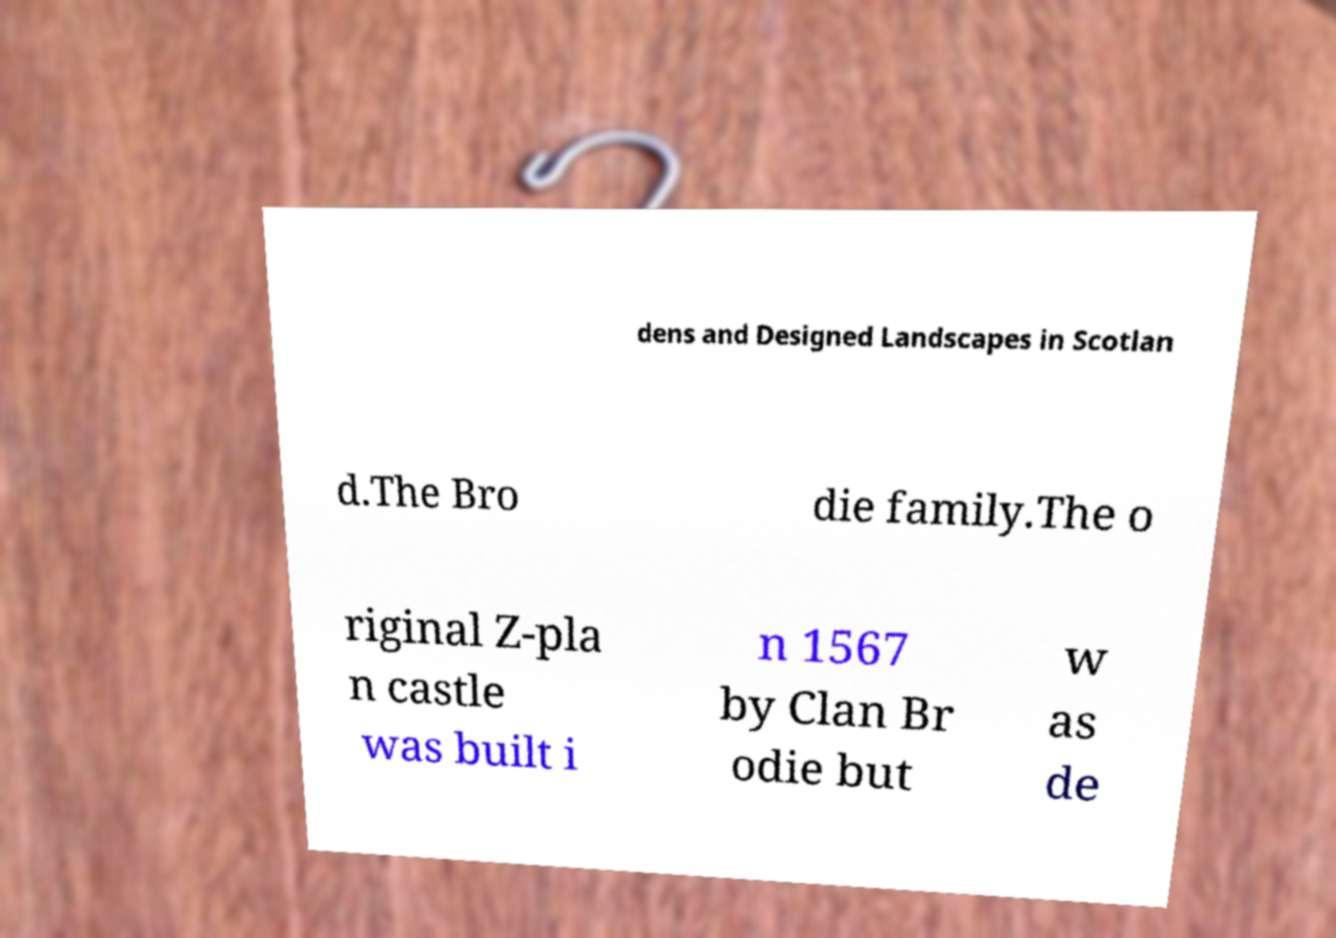Please read and relay the text visible in this image. What does it say? dens and Designed Landscapes in Scotlan d.The Bro die family.The o riginal Z-pla n castle was built i n 1567 by Clan Br odie but w as de 